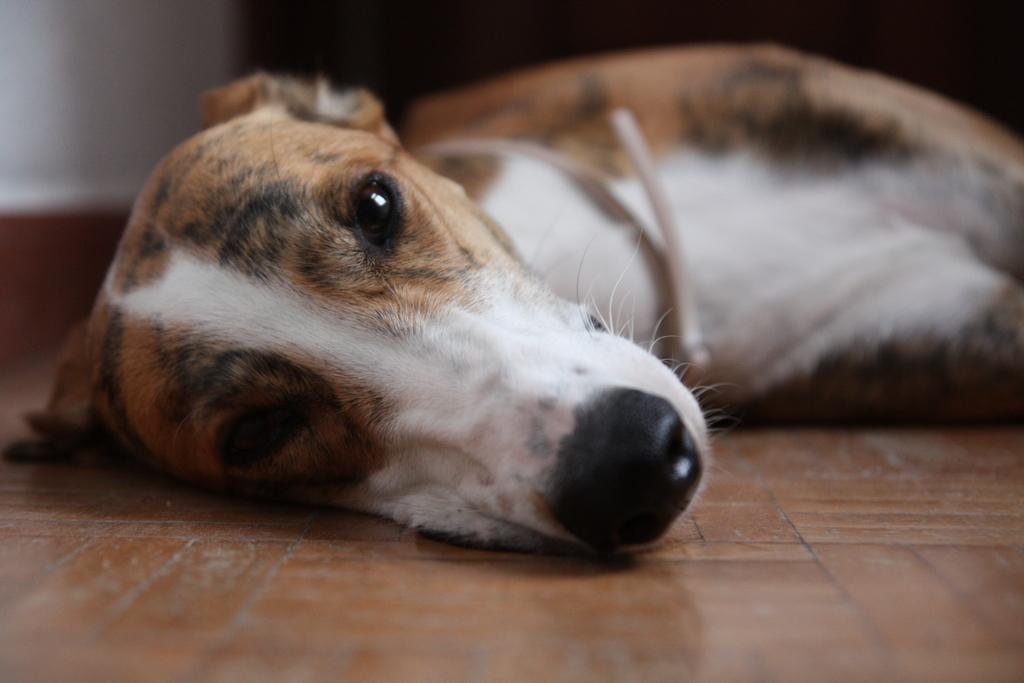What type of animal is present in the image? There is a dog in the image. What is the dog doing in the image? The dog is laying on the floor. What can be seen in the background of the image? There is a wall in the background of the image. What type of comfort does the dog provide to the person in the image? There is no person present in the image, so it is not possible to determine the comfort provided by the dog. 